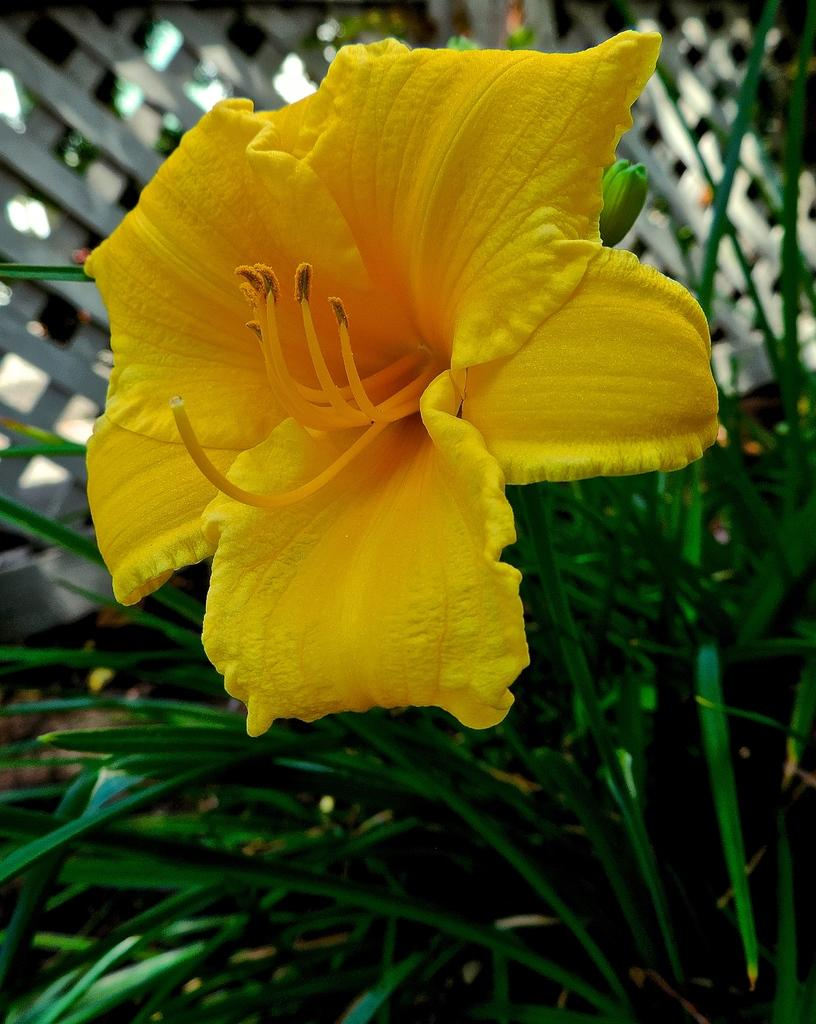What type of flower can be seen in the image? There is a yellow flower in the image. What can be seen in the background of the image? There is fencing visible in the background of the image. How many fish are swimming in the yellow flower in the image? There are no fish present in the image, as it features a yellow flower and fencing in the background. 